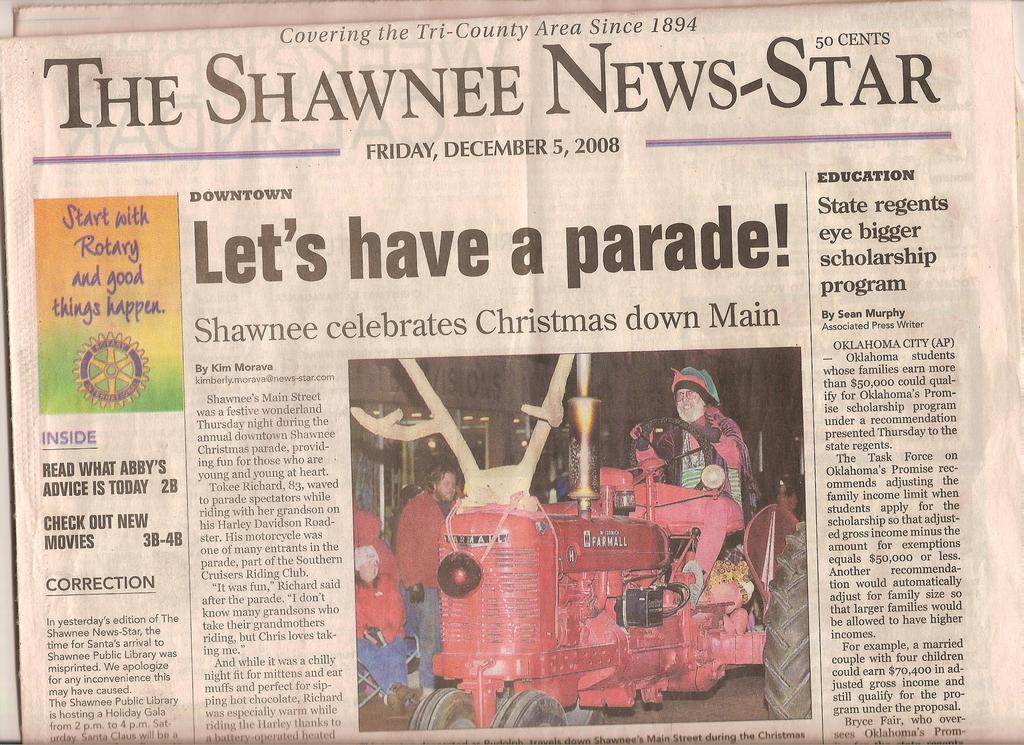<image>
Offer a succinct explanation of the picture presented. A newspaper called the Shawnee News-Star says Let's have a parade. 